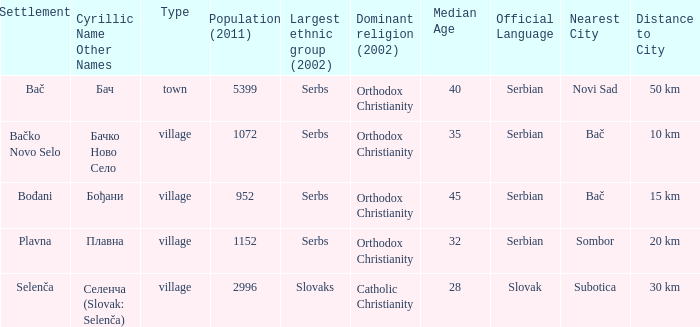How to you write  плавна with the latin alphabet? Plavna. 